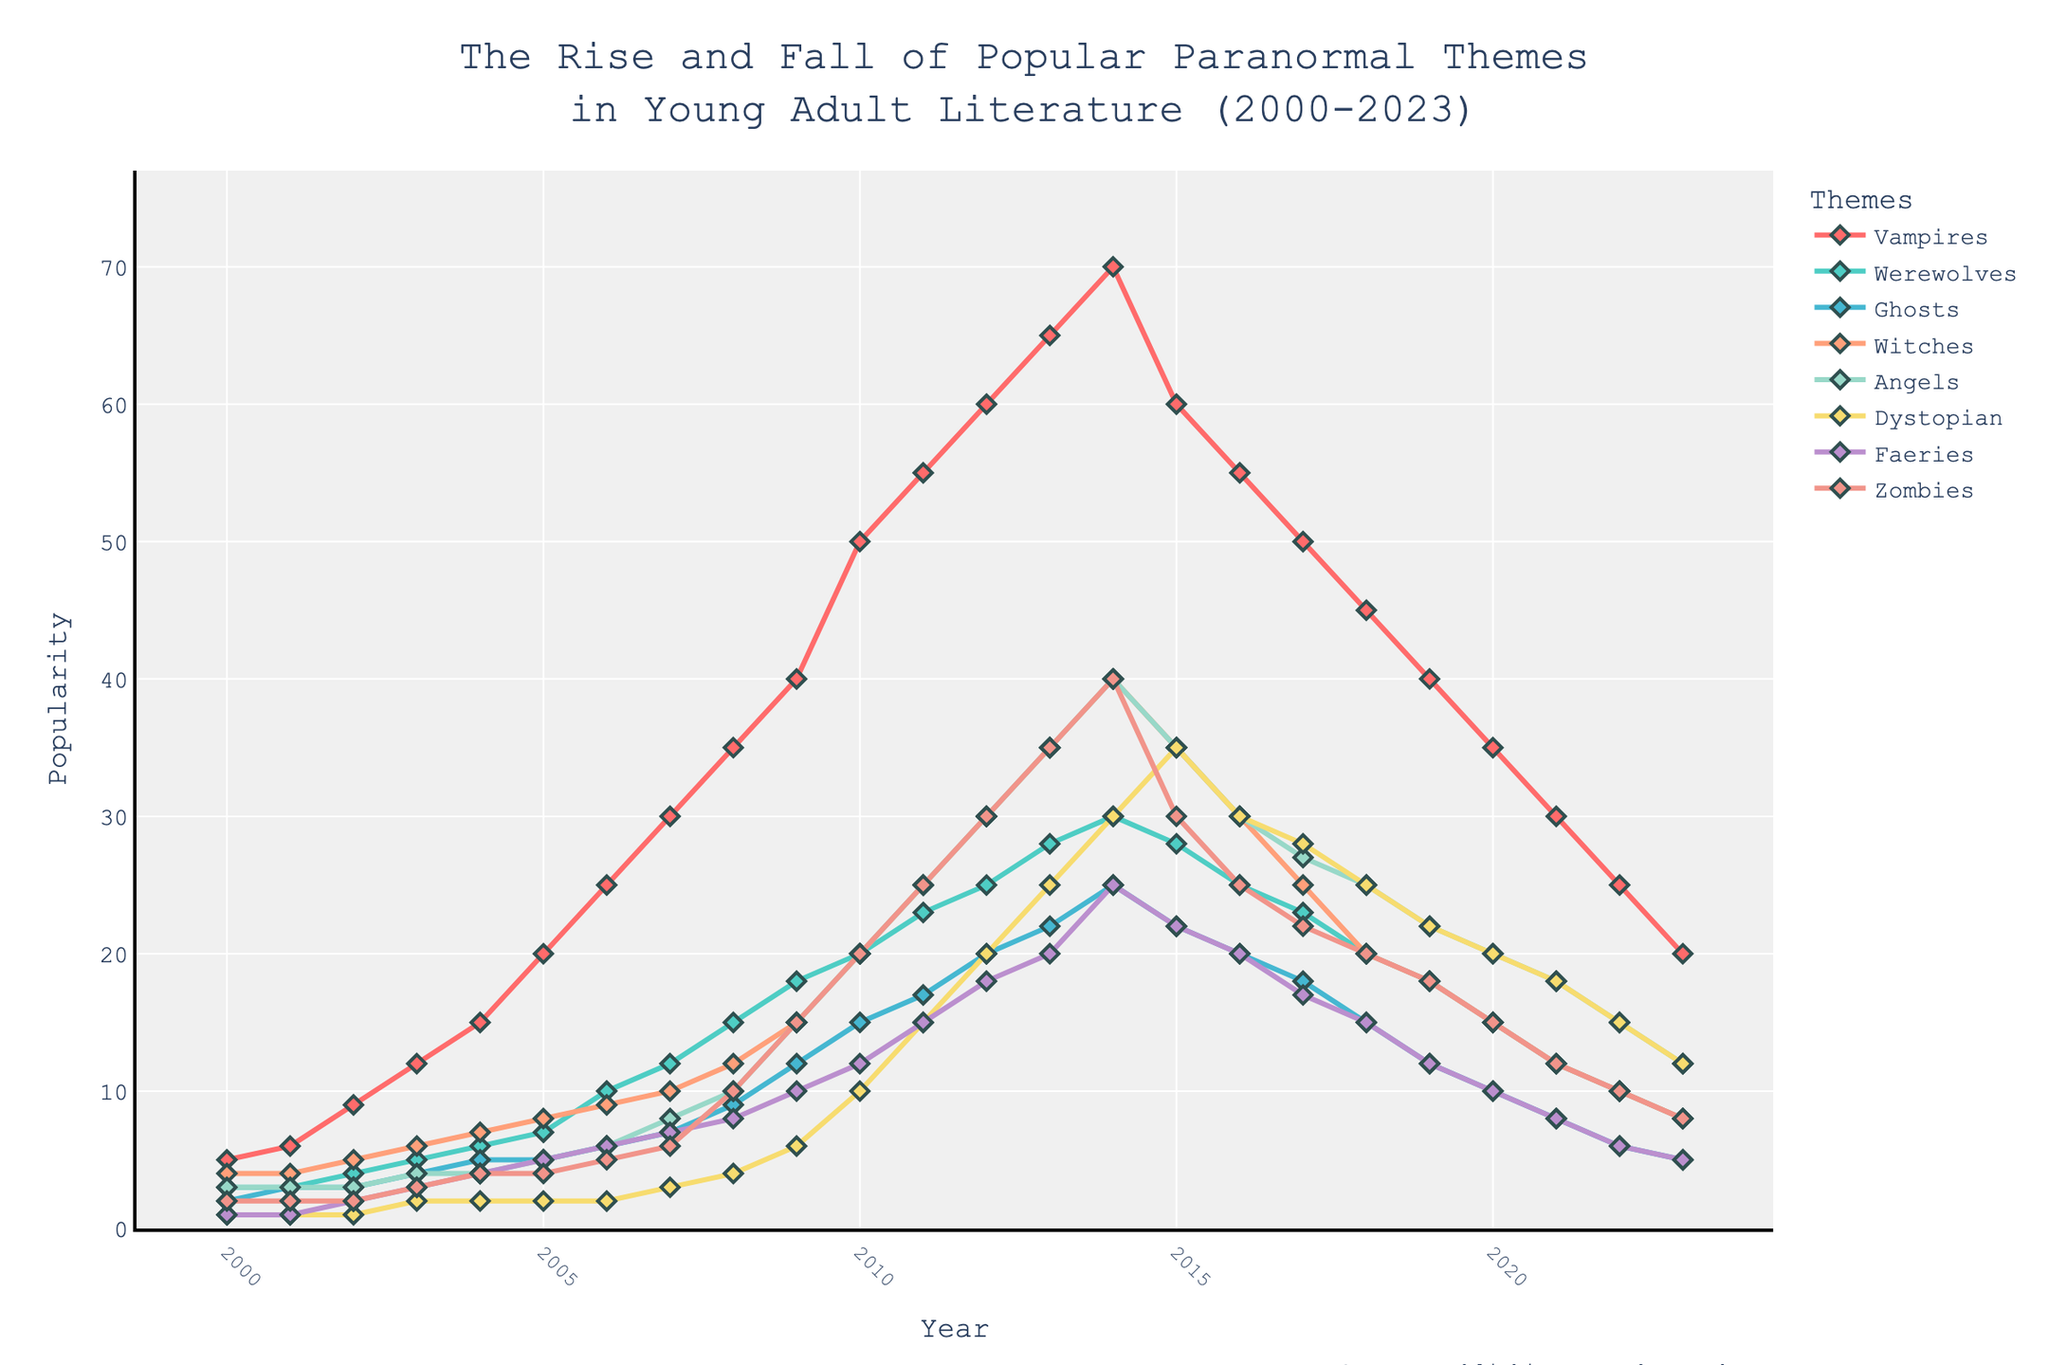What is the title of the plot? The title of the plot is located at the top center of the figure and it reads: 'The Rise and Fall of Popular Paranormal Themes in Young Adult Literature (2000-2023)'
Answer: 'The Rise and Fall of Popular Paranormal Themes in Young Adult Literature (2000-2023)' Which paranormal theme was the most popular in 2010? By examining the points for each theme in the year 2010, the line corresponding to "Vampires" is the highest, indicating it was the most popular theme in that year.
Answer: Vampires Between which years did the popularity of Zombies peak? By observing the graph for Zombies, the highest point occurs between 2013 and 2015, with the peak exactly at 2014.
Answer: 2014 How did the popularity of Werewolves change from 2000 to 2023? By tracing the line from 2000 to 2023 for Werewolves, you see it ascended gradually till around 2014, after which it started to decline until 2023.
Answer: It rose till 2014 and then declined till 2023 What can you say about the trend of Dystopian themes after 2015? The plot shows that Dystopian themes reached their peak popularity in 2015 and then steadily declined through 2023.
Answer: Declined after 2015 Which theme saw the steepest rise in popularity between 2008 and 2013? The largest incline observed on the plot between 2008 and 2013 occurs for the "Vampires" theme, indicating it saw the steepest rise.
Answer: Vampires Compare the popularity of Angels and Witches in 2021. Which one was more popular and by how much? The graph indicates that in 2021, the popularity of Angels was higher than Witches. The point for Angels is at 18 units whereas Witches is at 12 units, showing that Angels were more popular by 6 units.
Answer: Angels, by 6 units What is the least popular theme in 2023? The points for each theme in 2023 show that "Faeries" and "Ghosts" are the lowest, having equal values, so both are the least popular.
Answer: Faeries and Ghosts What does the hover mode in this figure provide? The hover mode being 'x unified' shows all theme values at a given year when you hover over a specific point on the x-axis.
Answer: All theme values at a given year 